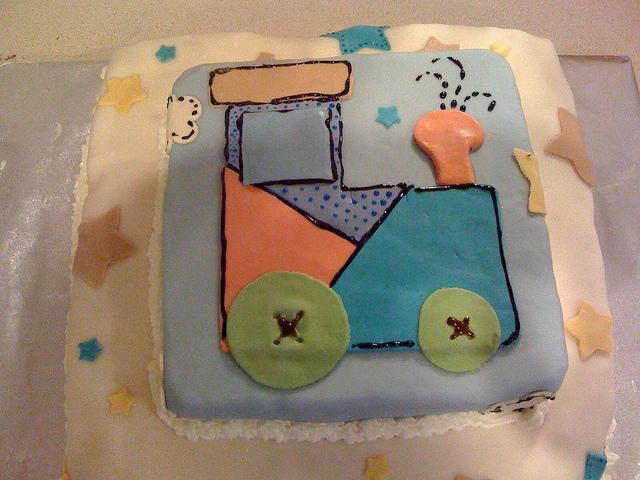How many cakes can be seen?
Give a very brief answer. 2. How many bottles are seen?
Give a very brief answer. 0. 